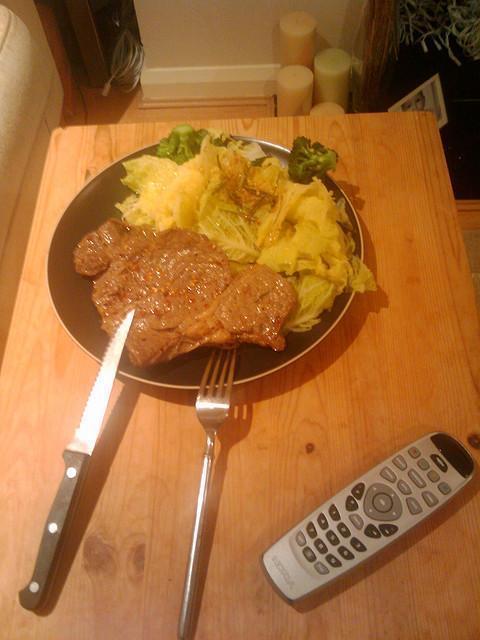How many bananas doe the guy have in his back pocket?
Give a very brief answer. 0. 